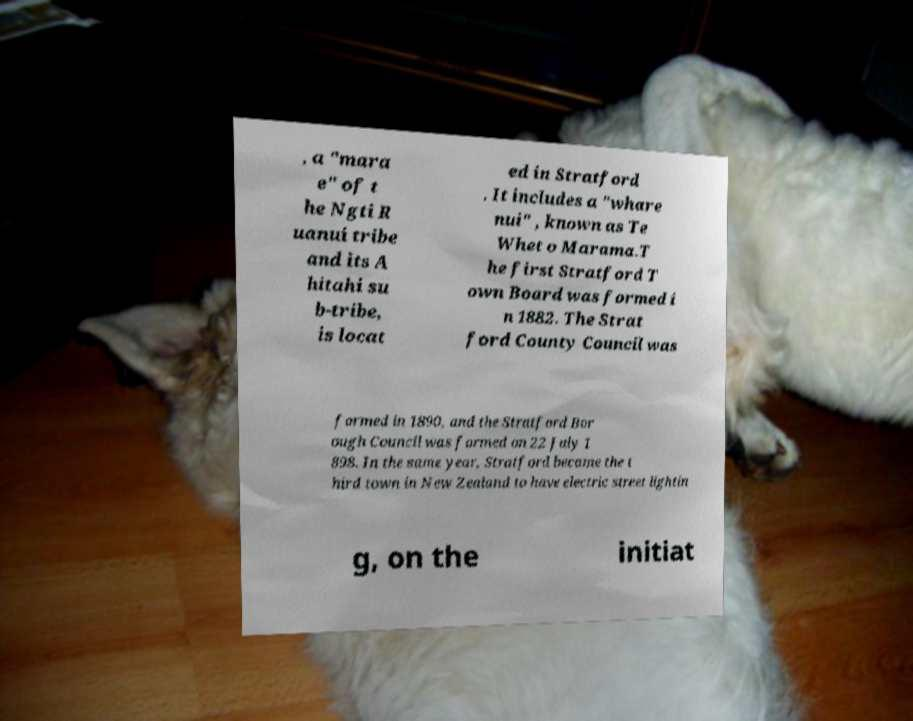Can you read and provide the text displayed in the image?This photo seems to have some interesting text. Can you extract and type it out for me? , a "mara e" of t he Ngti R uanui tribe and its A hitahi su b-tribe, is locat ed in Stratford . It includes a "whare nui" , known as Te Whet o Marama.T he first Stratford T own Board was formed i n 1882. The Strat ford County Council was formed in 1890, and the Stratford Bor ough Council was formed on 22 July 1 898. In the same year, Stratford became the t hird town in New Zealand to have electric street lightin g, on the initiat 